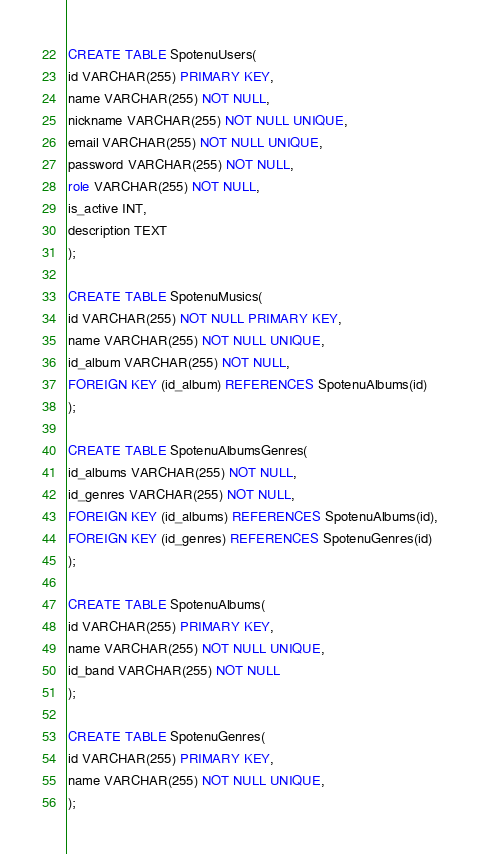<code> <loc_0><loc_0><loc_500><loc_500><_SQL_>CREATE TABLE SpotenuUsers(
id VARCHAR(255) PRIMARY KEY,
name VARCHAR(255) NOT NULL, 
nickname VARCHAR(255) NOT NULL UNIQUE,
email VARCHAR(255) NOT NULL UNIQUE,
password VARCHAR(255) NOT NULL,
role VARCHAR(255) NOT NULL, 
is_active INT,
description TEXT 
);

CREATE TABLE SpotenuMusics(
id VARCHAR(255) NOT NULL PRIMARY KEY,
name VARCHAR(255) NOT NULL UNIQUE,
id_album VARCHAR(255) NOT NULL,
FOREIGN KEY (id_album) REFERENCES SpotenuAlbums(id)
);

CREATE TABLE SpotenuAlbumsGenres(
id_albums VARCHAR(255) NOT NULL,
id_genres VARCHAR(255) NOT NULL,
FOREIGN KEY (id_albums) REFERENCES SpotenuAlbums(id),
FOREIGN KEY (id_genres) REFERENCES SpotenuGenres(id)
);

CREATE TABLE SpotenuAlbums(
id VARCHAR(255) PRIMARY KEY,
name VARCHAR(255) NOT NULL UNIQUE,
id_band VARCHAR(255) NOT NULL
);

CREATE TABLE SpotenuGenres(
id VARCHAR(255) PRIMARY KEY,
name VARCHAR(255) NOT NULL UNIQUE,
);</code> 